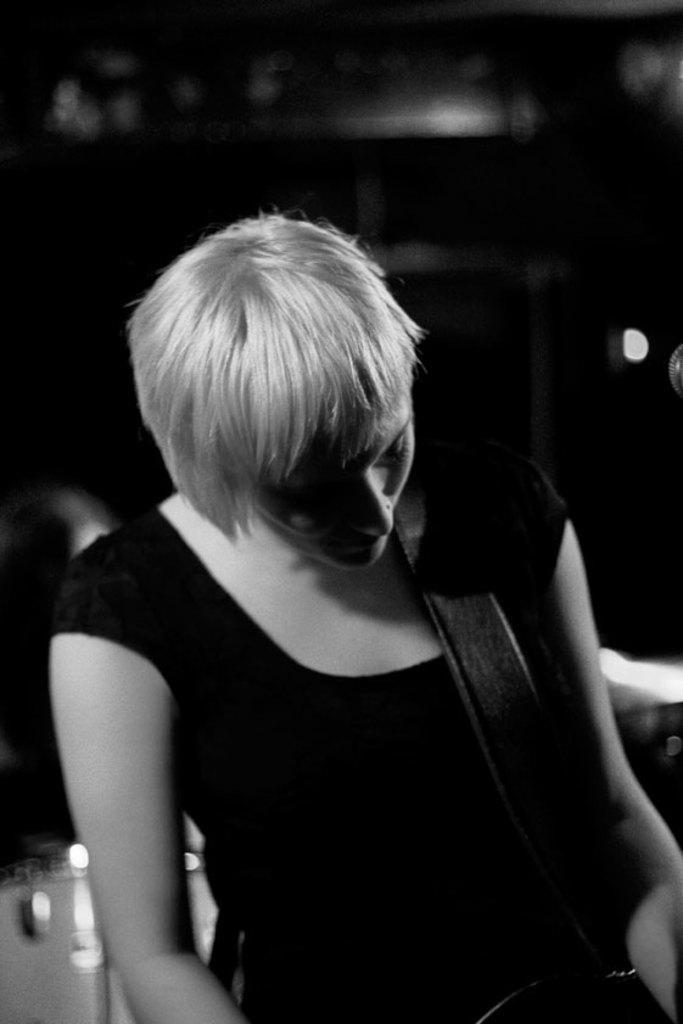Please provide a concise description of this image. In this black and white picture there is a woman. She is carrying an object. Background is blurry. 